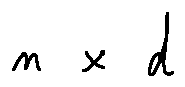<formula> <loc_0><loc_0><loc_500><loc_500>n \times d</formula> 